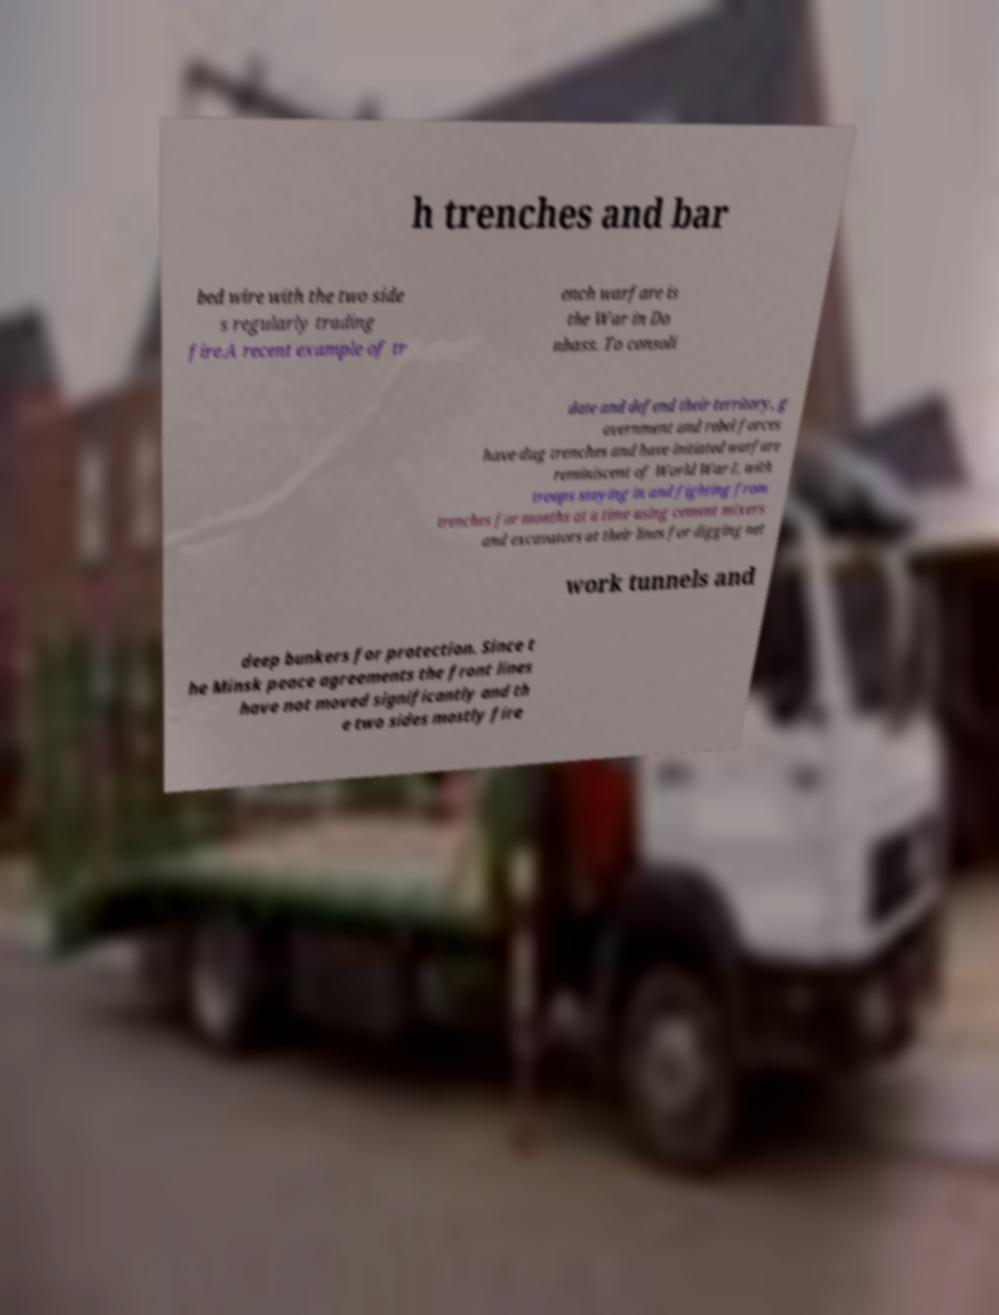There's text embedded in this image that I need extracted. Can you transcribe it verbatim? h trenches and bar bed wire with the two side s regularly trading fire.A recent example of tr ench warfare is the War in Do nbass. To consoli date and defend their territory, g overnment and rebel forces have dug trenches and have initiated warfare reminiscent of World War I, with troops staying in and fighting from trenches for months at a time using cement mixers and excavators at their lines for digging net work tunnels and deep bunkers for protection. Since t he Minsk peace agreements the front lines have not moved significantly and th e two sides mostly fire 